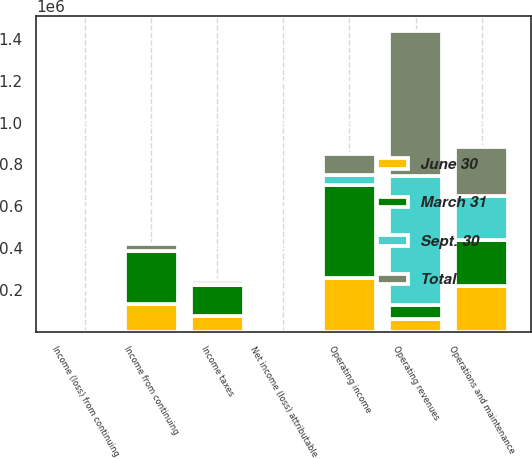Convert chart to OTSL. <chart><loc_0><loc_0><loc_500><loc_500><stacked_bar_chart><ecel><fcel>Operating revenues<fcel>Operations and maintenance<fcel>Operating income<fcel>Income taxes<fcel>Income from continuing<fcel>Net income (loss) attributable<fcel>Income (loss) from continuing<nl><fcel>Sept. 30<fcel>620631<fcel>210663<fcel>48007<fcel>4645<fcel>284<fcel>0.08<fcel>0.07<nl><fcel>June 30<fcel>62348<fcel>216236<fcel>254489<fcel>76689<fcel>130930<fcel>1.12<fcel>1.12<nl><fcel>March 31<fcel>62348<fcel>220729<fcel>447970<fcel>147116<fcel>252874<fcel>2.23<fcel>2.23<nl><fcel>Total<fcel>693122<fcel>237141<fcel>101289<fcel>18157<fcel>34905<fcel>0.21<fcel>0.24<nl></chart> 